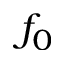<formula> <loc_0><loc_0><loc_500><loc_500>f _ { 0 }</formula> 